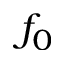<formula> <loc_0><loc_0><loc_500><loc_500>f _ { 0 }</formula> 